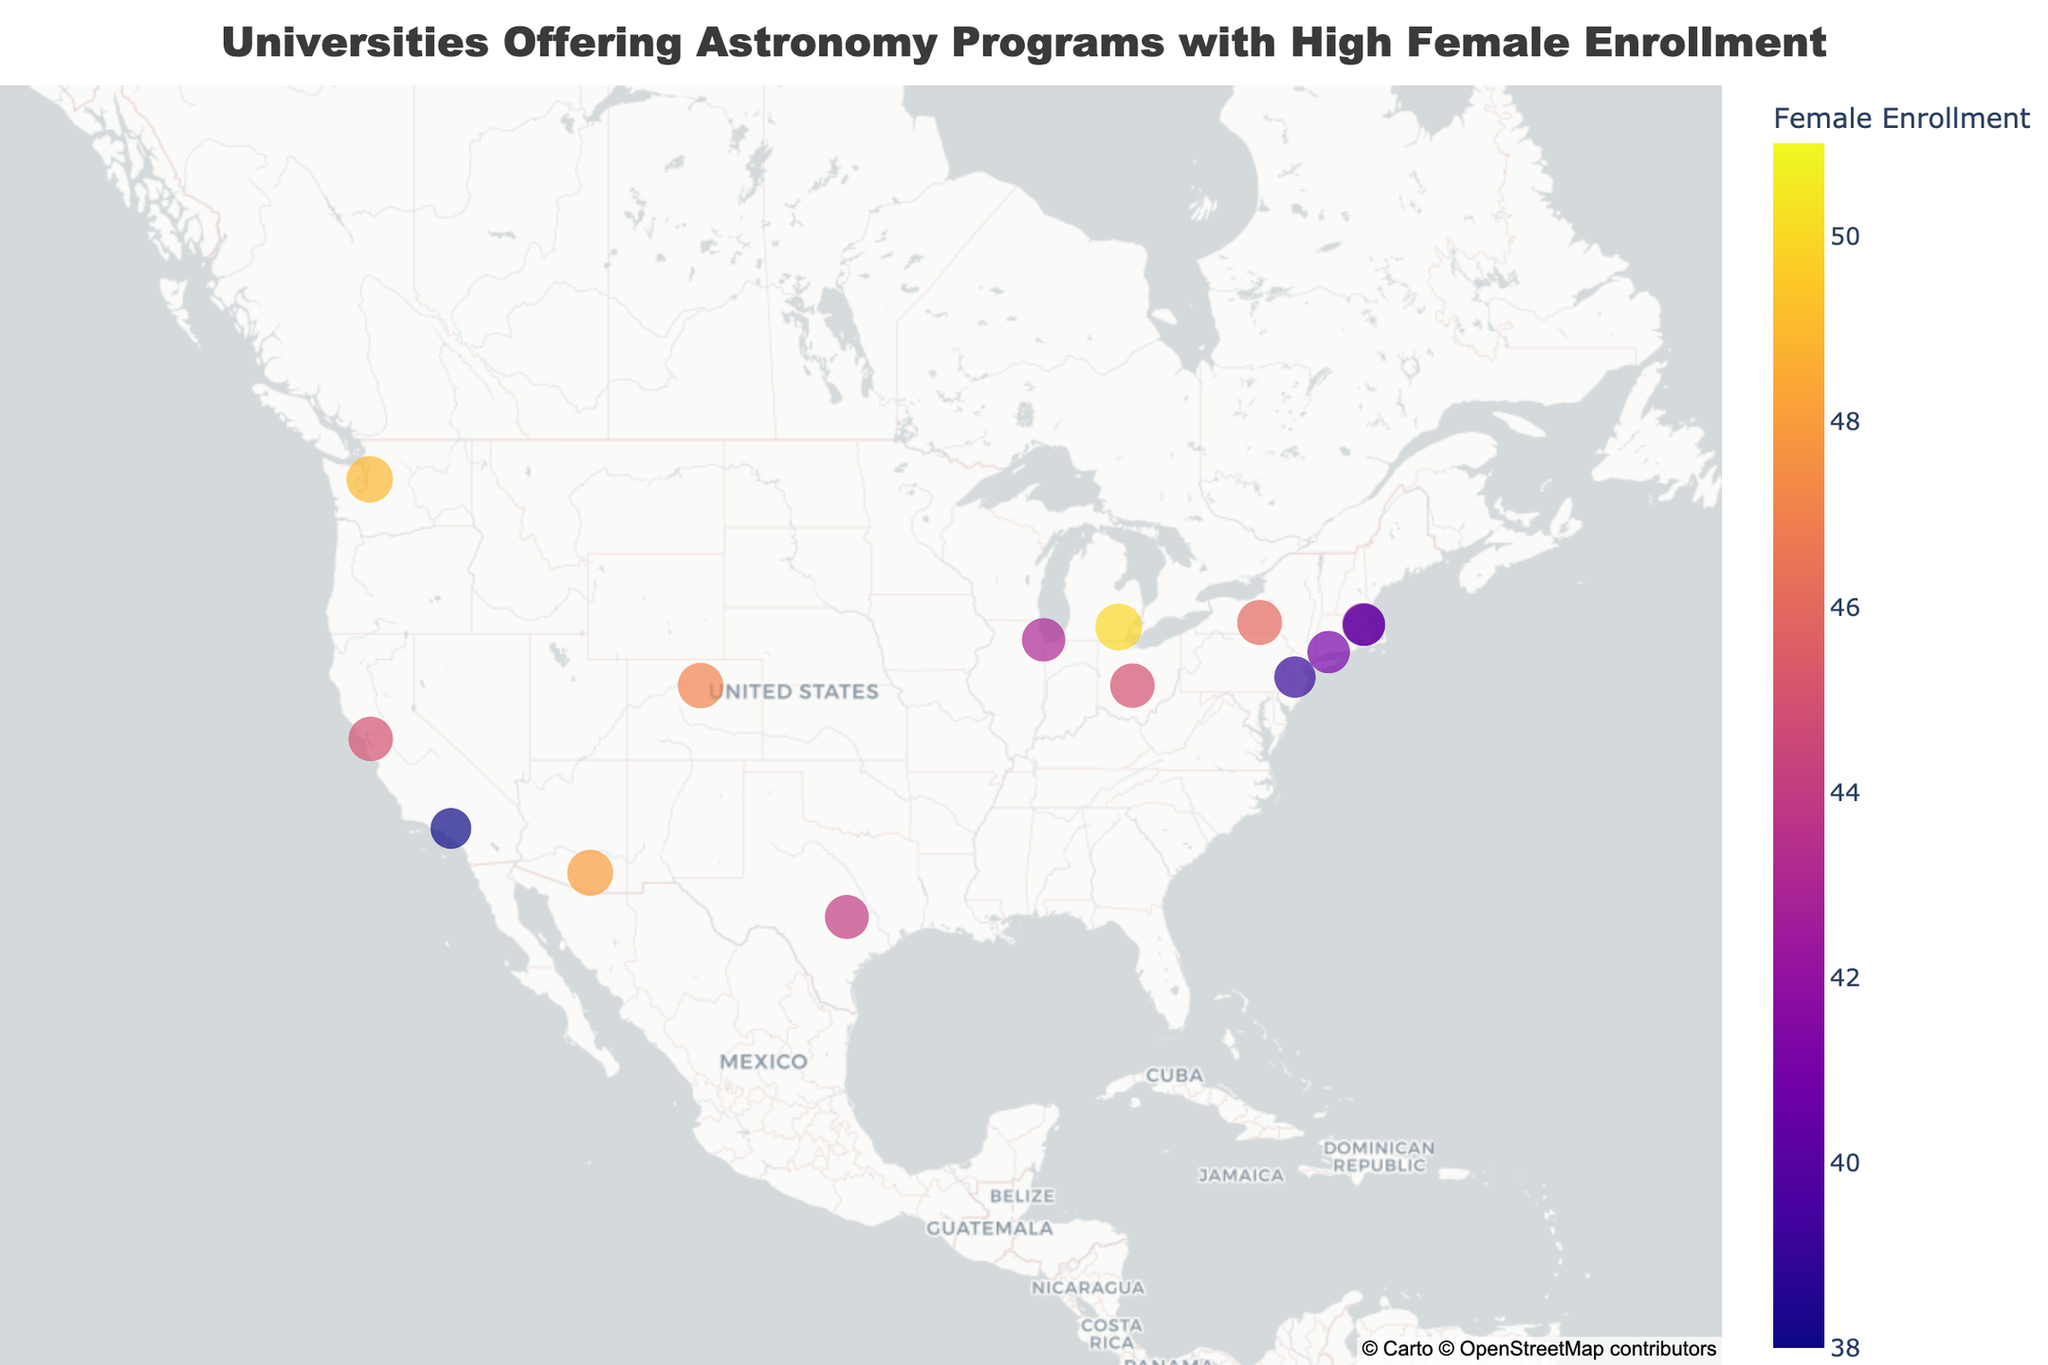Which university has the highest female enrollment in astronomy programs? By examining the size and color intensity of the points, we can identify the point representing the university with the highest enrollment. The largest circle with the darkest shade of purple corresponds to University of Hawaii at Manoa.
Answer: University of Hawaii at Manoa What is the title of the plot? The title is usually displayed at the top of the plot and is set to be very prominent in size and color.
Answer: Universities Offering Astronomy Programs with High Female Enrollment Among Harvard, MIT, and Yale, which university has a higher female enrollment? By hovering over each university represented on the map, we can see their respective female enrollment values: Harvard (42), MIT (40), Yale (41). Comparing these values, Harvard has the highest number.
Answer: Harvard Which university in California has the higher female enrollment, UC Berkeley or Caltech? Looking at the points for both universities in California (UC Berkeley and Caltech) and hovering over them reveals their female enrollment values: UC Berkeley (45), Caltech (38). UC Berkeley has a higher female enrollment.
Answer: UC Berkeley What’s the average female enrollment of the universities located on the East Coast (Harvard, MIT, Yale, Princeton)? First, identify the female enrollment numbers for each of these universities: Harvard (42), MIT (40), Yale (41), Princeton (39). Sum these values and divide by the number of universities: (42+40+41+39)/4 = 162/4 = 40.5.
Answer: 40.5 Which university has a higher female enrollment, University of Chicago or Ohio State University? By comparing the values: University of Chicago (43) and Ohio State University (45), we see that Ohio State University has a slightly higher female enrollment.
Answer: Ohio State University How does the female enrollment at University of Colorado Boulder compare to that at University of Texas at Austin? The female enrollment at University of Colorado Boulder (47) is compared to University of Texas at Austin (44). Boulder has a higher female enrollment.
Answer: University of Colorado Boulder Which university is located furthest west and what is its female enrollment? The point located furthest to the west on the map (leftmost) corresponds to University of Hawaii at Manoa with a female enrollment of 51.
Answer: University of Hawaii at Manoa What is the range of female enrollment among all the universities listed? Identify the minimum (38 at Caltech) and maximum (51 at University of Hawaii) female enrollment values and then calculate the range: 51 - 38 = 13.
Answer: 13 How many universities have a female enrollment above 45? Identify the universities with enrollment values greater than 45: University of Hawaii at Manoa (51), University of Washington (49), University of Colorado Boulder (47), University of Michigan (50), and Cornell University (46). Count these universities.
Answer: 5 